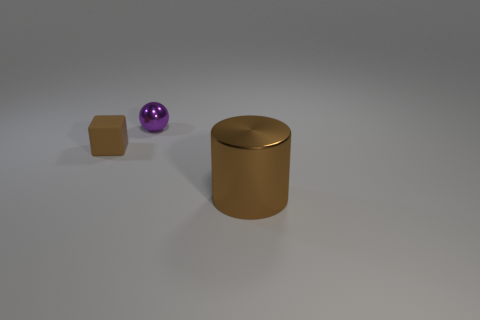Add 2 blue matte cubes. How many objects exist? 5 Subtract all cubes. How many objects are left? 2 Add 2 brown matte cubes. How many brown matte cubes are left? 3 Add 2 tiny cubes. How many tiny cubes exist? 3 Subtract 0 gray balls. How many objects are left? 3 Subtract all tiny rubber things. Subtract all yellow rubber things. How many objects are left? 2 